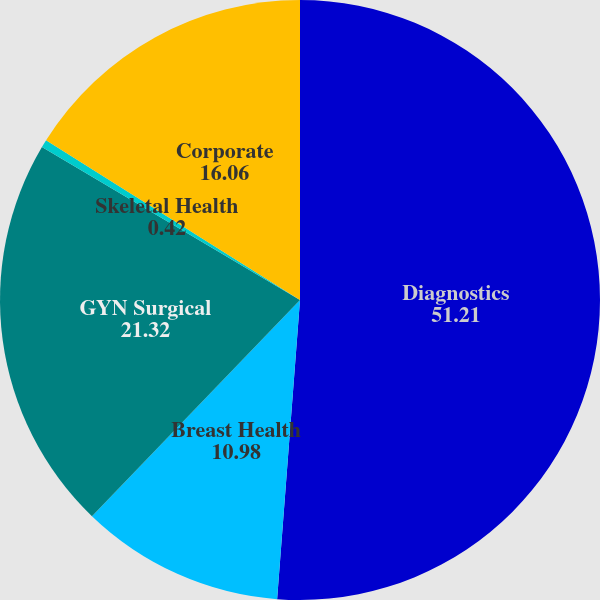<chart> <loc_0><loc_0><loc_500><loc_500><pie_chart><fcel>Diagnostics<fcel>Breast Health<fcel>GYN Surgical<fcel>Skeletal Health<fcel>Corporate<nl><fcel>51.21%<fcel>10.98%<fcel>21.32%<fcel>0.42%<fcel>16.06%<nl></chart> 